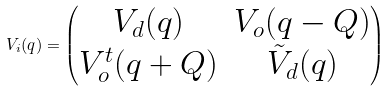Convert formula to latex. <formula><loc_0><loc_0><loc_500><loc_500>V _ { i } ( q ) = \begin{pmatrix} V _ { d } ( q ) & V _ { o } ( q - Q ) \\ V _ { o } ^ { t } ( q + Q ) & \tilde { V } _ { d } ( q ) \end{pmatrix}</formula> 